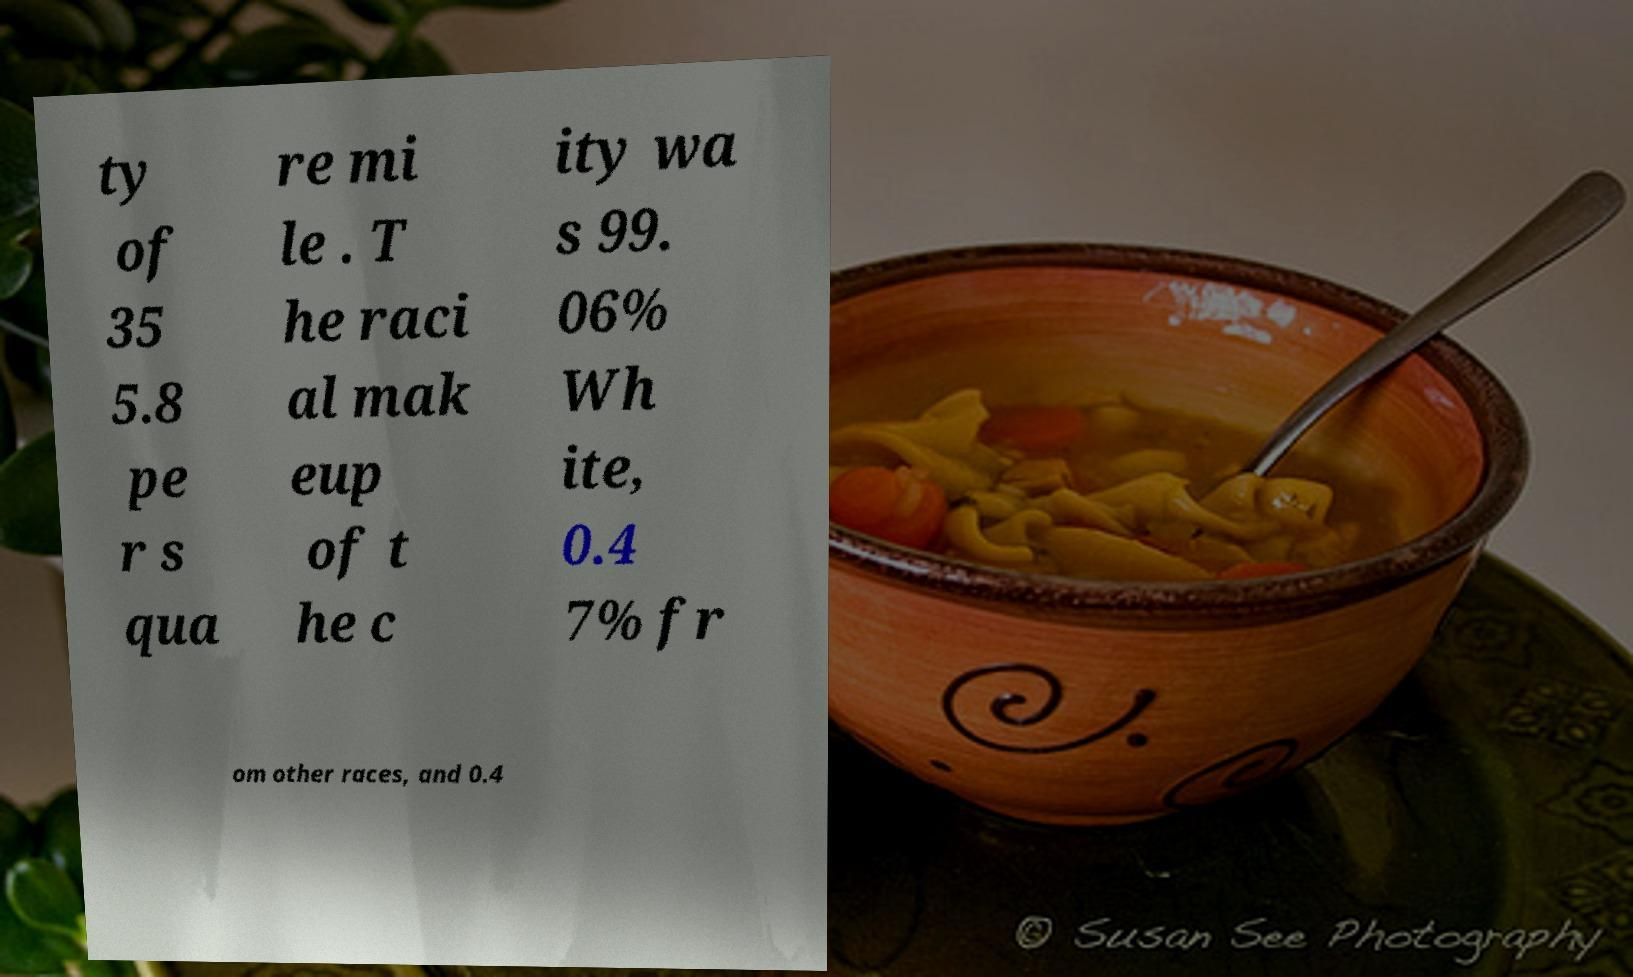Could you extract and type out the text from this image? ty of 35 5.8 pe r s qua re mi le . T he raci al mak eup of t he c ity wa s 99. 06% Wh ite, 0.4 7% fr om other races, and 0.4 